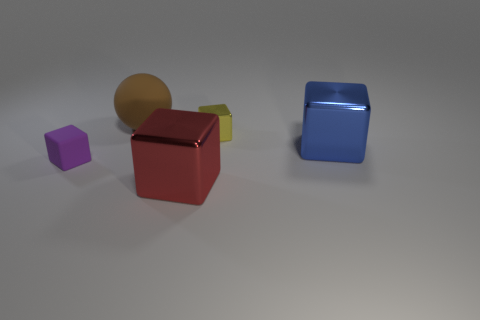What is the material of the large cube that is on the right side of the big block left of the yellow shiny thing?
Give a very brief answer. Metal. Is there another tiny shiny thing that has the same shape as the red metal object?
Ensure brevity in your answer.  Yes. What number of other things are the same shape as the large red metallic thing?
Provide a short and direct response. 3. The object that is both in front of the blue object and to the right of the tiny purple block has what shape?
Your answer should be compact. Cube. What size is the thing that is to the left of the large matte thing?
Give a very brief answer. Small. Does the red shiny cube have the same size as the yellow object?
Your answer should be very brief. No. Is the number of brown matte things left of the brown matte sphere less than the number of things that are behind the large blue thing?
Provide a succinct answer. Yes. There is a object that is right of the big brown thing and left of the yellow block; how big is it?
Provide a short and direct response. Large. There is a large block in front of the large block on the right side of the red shiny thing; is there a small thing left of it?
Offer a terse response. Yes. Are any large purple rubber spheres visible?
Make the answer very short. No. 